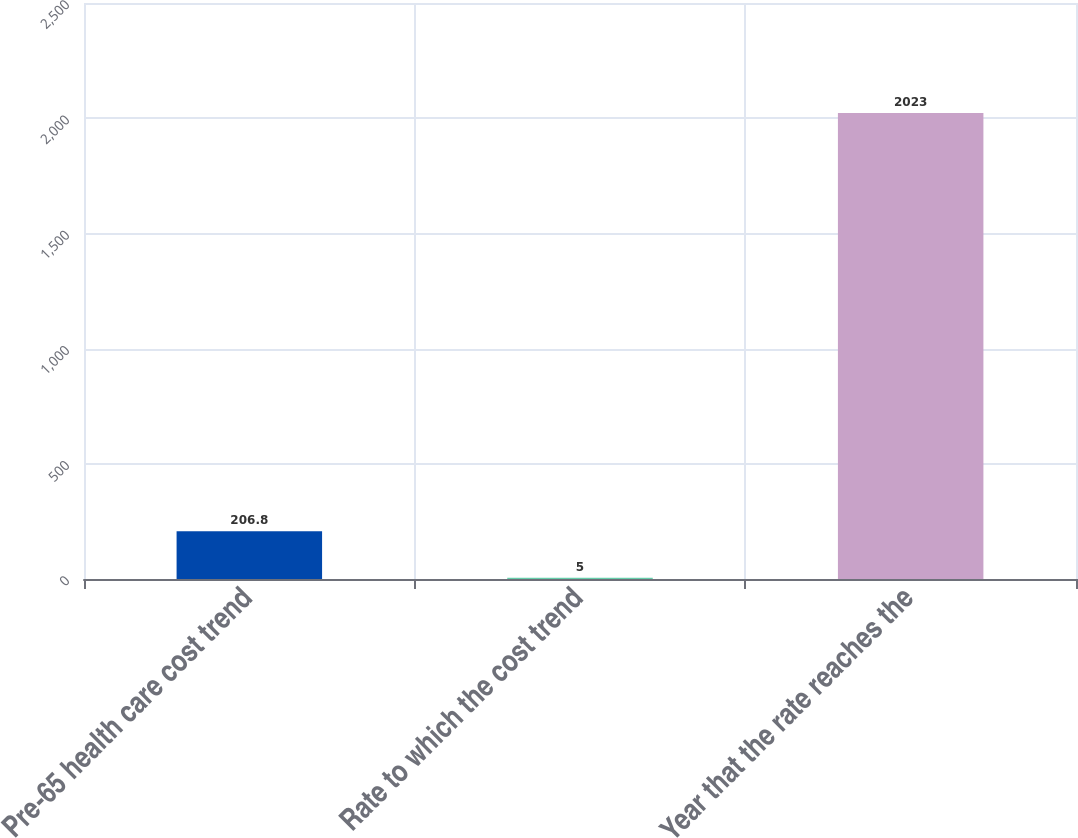Convert chart. <chart><loc_0><loc_0><loc_500><loc_500><bar_chart><fcel>Pre-65 health care cost trend<fcel>Rate to which the cost trend<fcel>Year that the rate reaches the<nl><fcel>206.8<fcel>5<fcel>2023<nl></chart> 